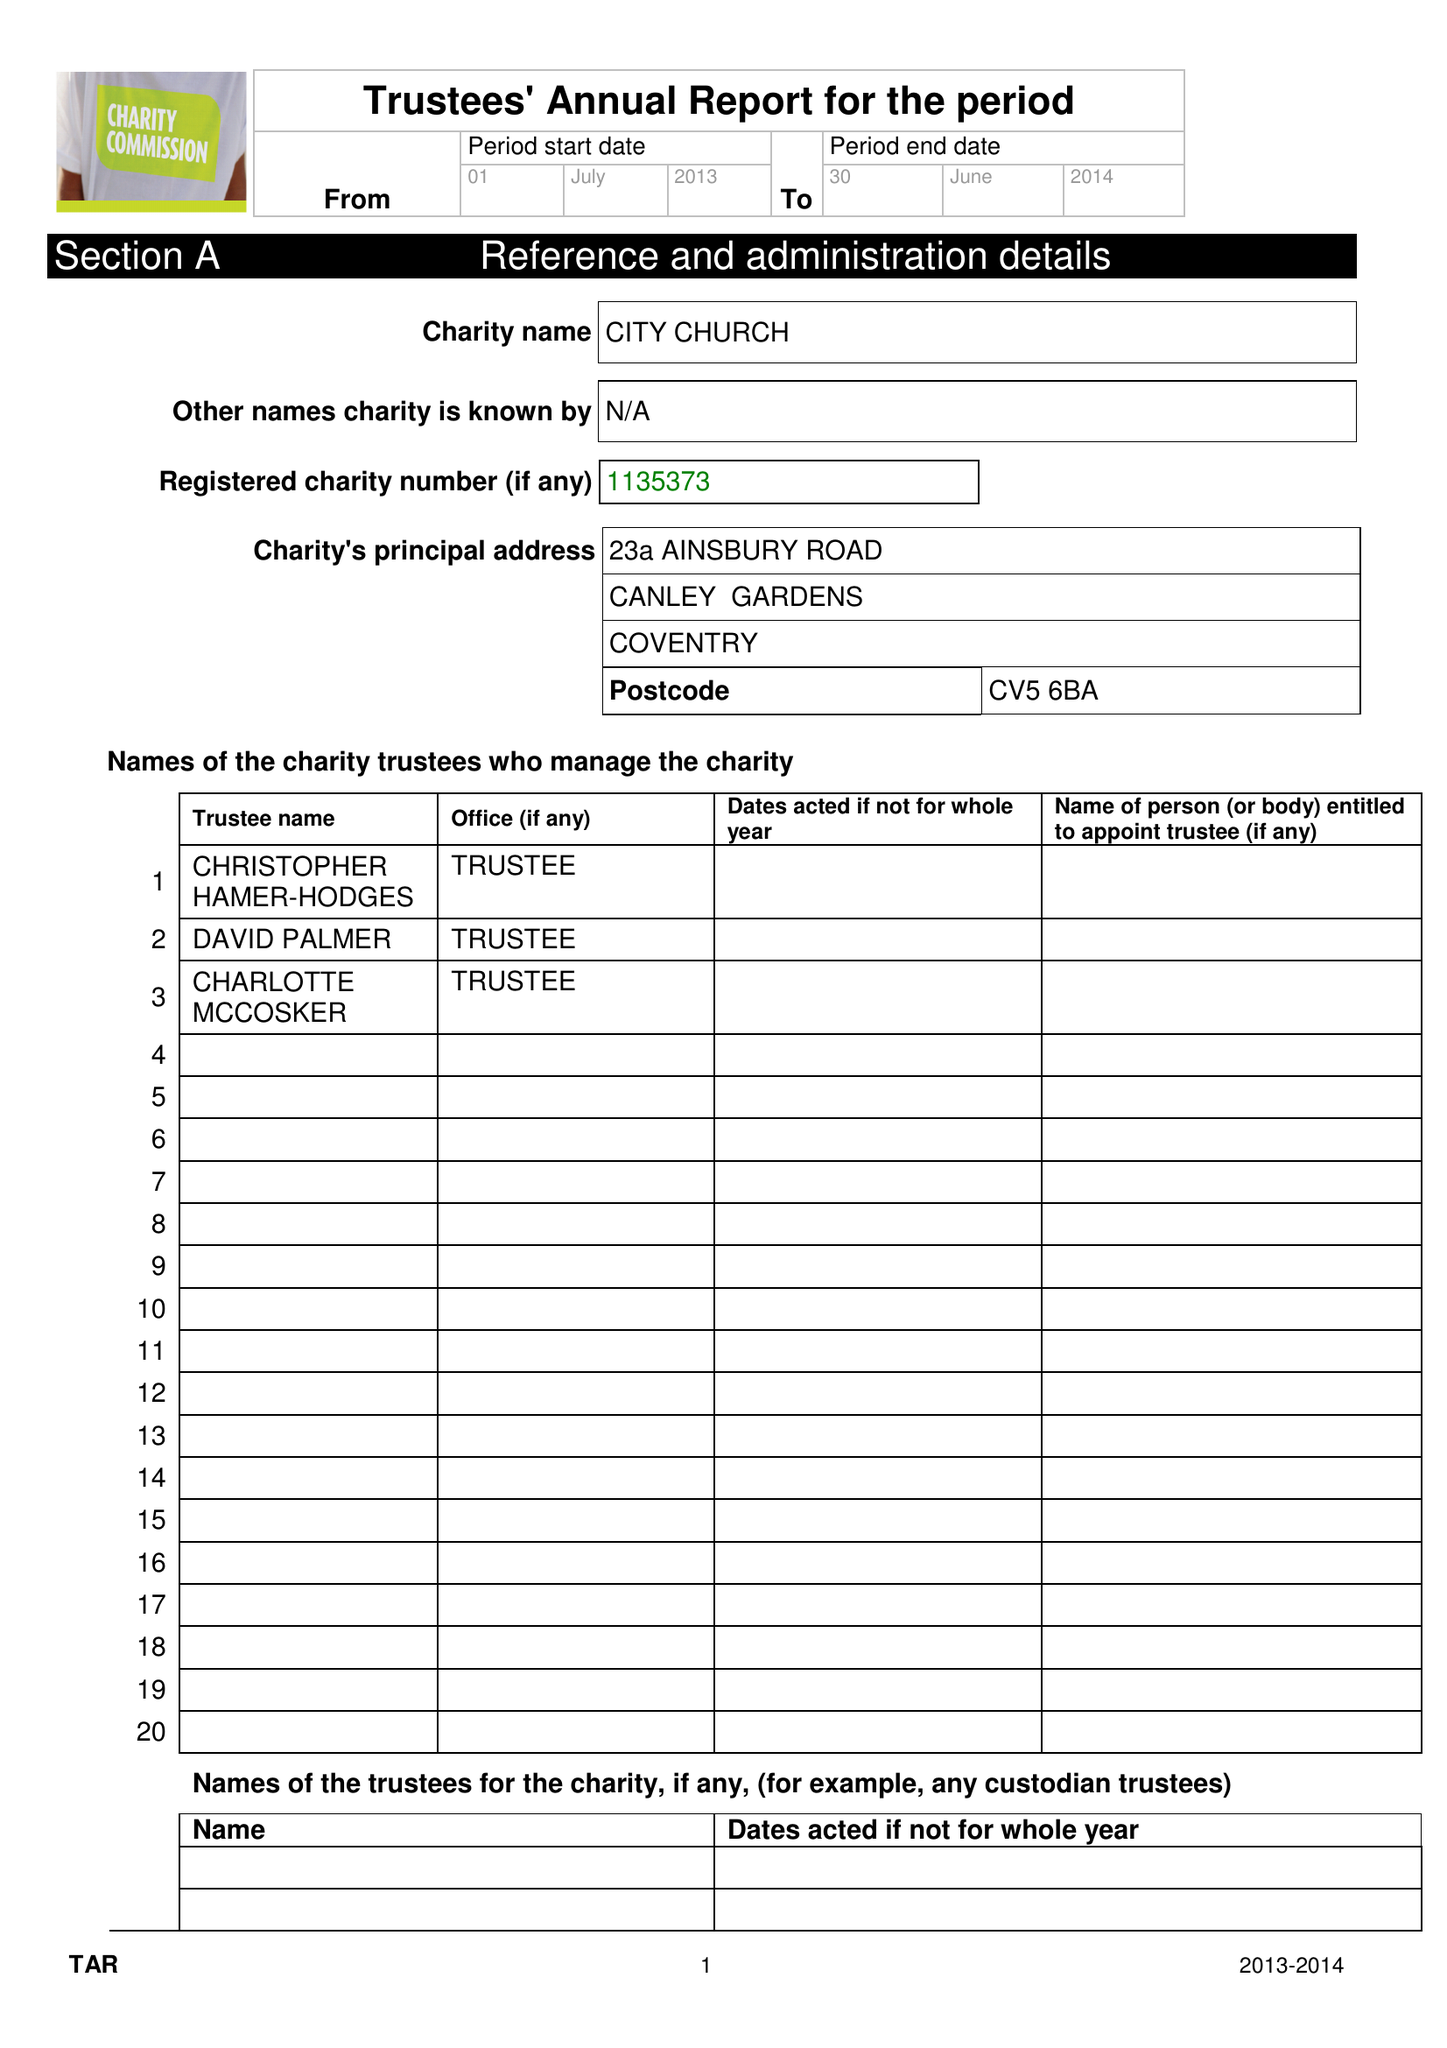What is the value for the charity_number?
Answer the question using a single word or phrase. 1135373 